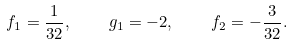<formula> <loc_0><loc_0><loc_500><loc_500>f _ { 1 } = { \frac { 1 } { 3 2 } } , \quad g _ { 1 } = - 2 , \quad f _ { 2 } = - { \frac { 3 } { 3 2 } } .</formula> 